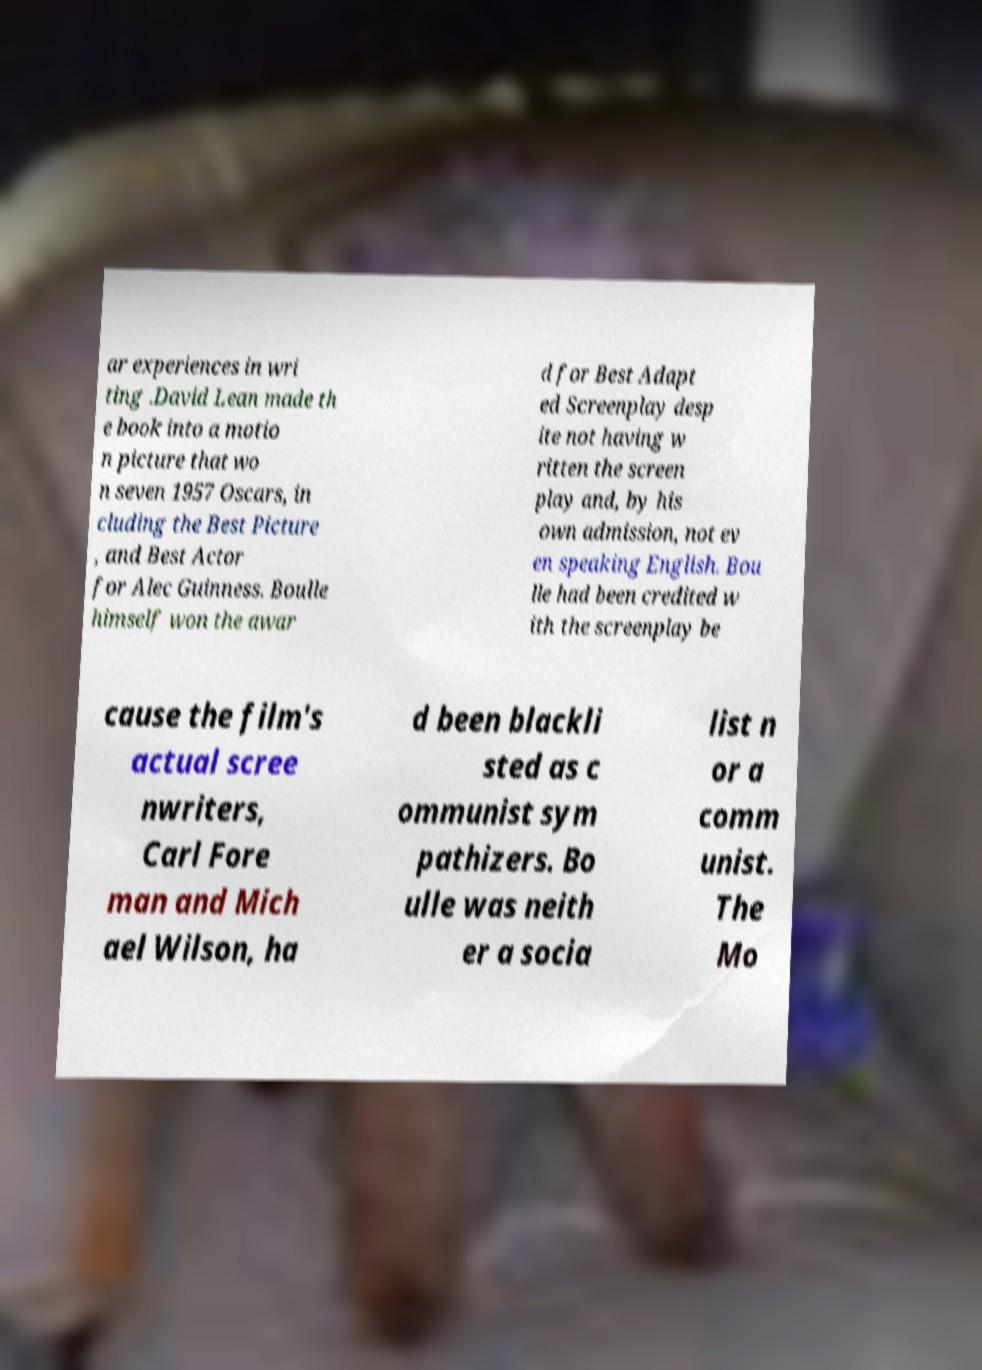I need the written content from this picture converted into text. Can you do that? ar experiences in wri ting .David Lean made th e book into a motio n picture that wo n seven 1957 Oscars, in cluding the Best Picture , and Best Actor for Alec Guinness. Boulle himself won the awar d for Best Adapt ed Screenplay desp ite not having w ritten the screen play and, by his own admission, not ev en speaking English. Bou lle had been credited w ith the screenplay be cause the film's actual scree nwriters, Carl Fore man and Mich ael Wilson, ha d been blackli sted as c ommunist sym pathizers. Bo ulle was neith er a socia list n or a comm unist. The Mo 